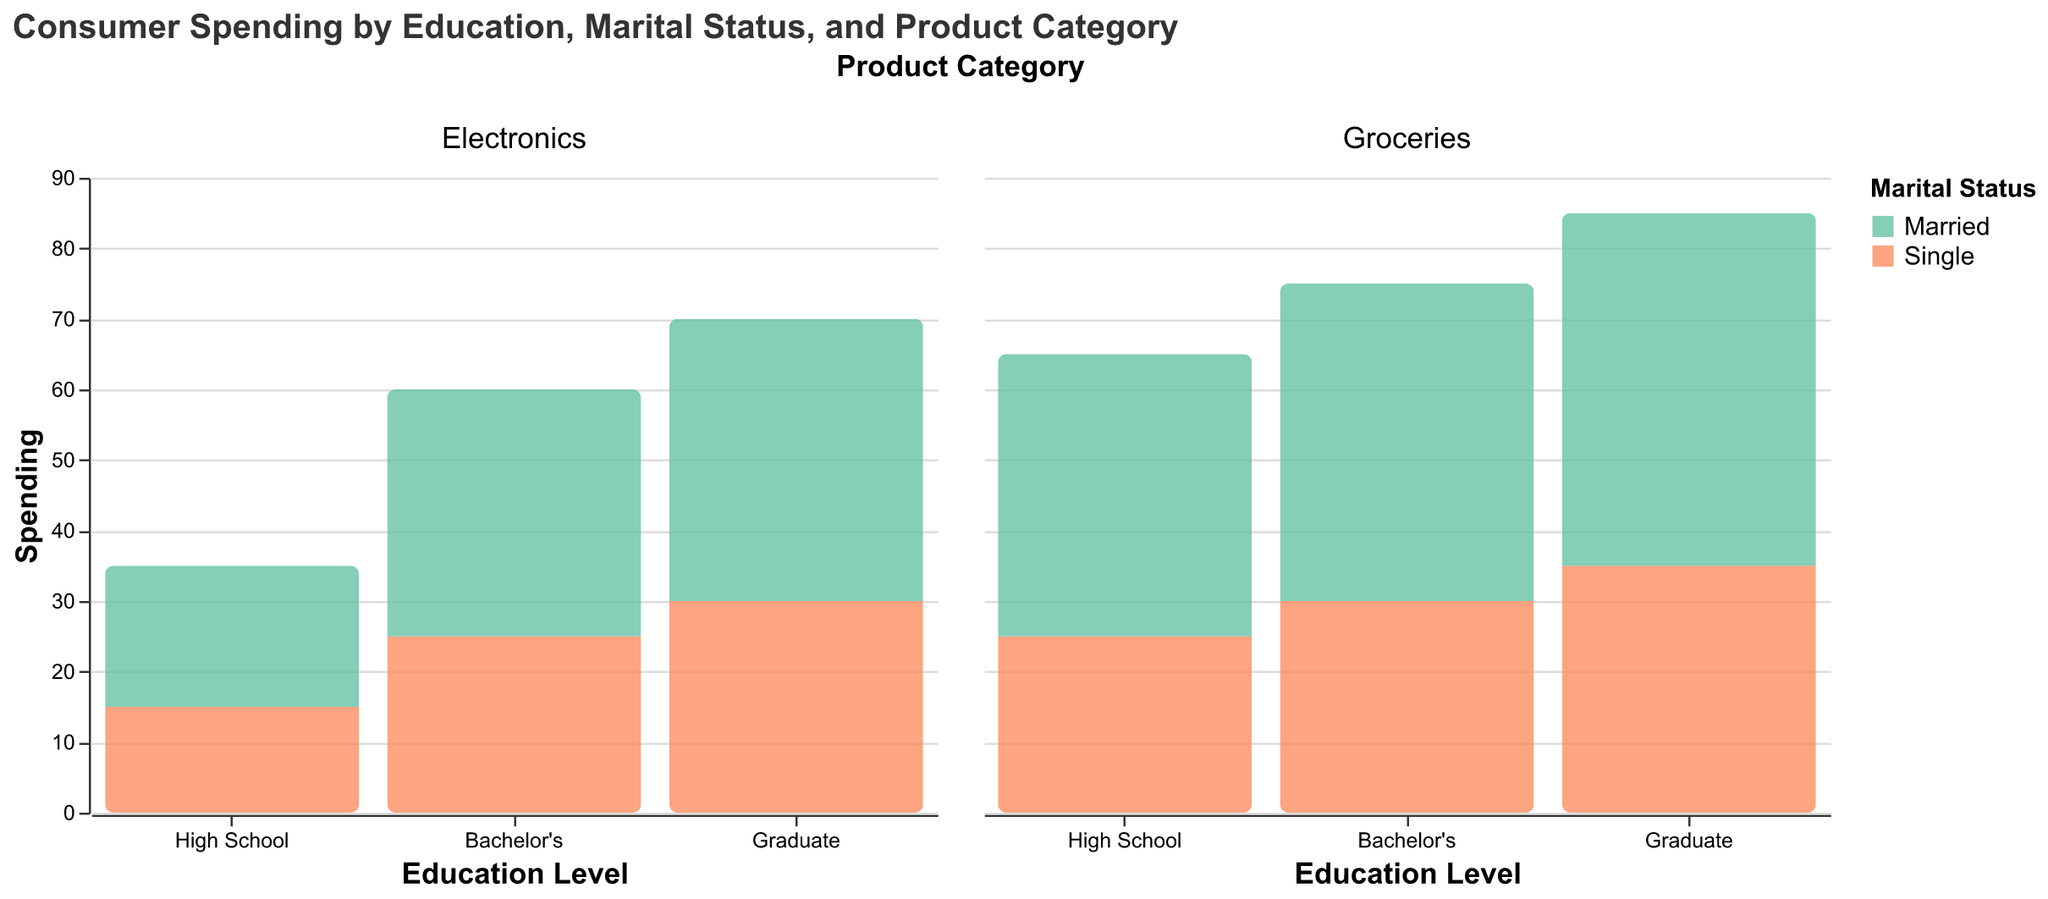What is the title of the figure? The title is usually displayed at the top of the figure. In this case, the title is "Consumer Spending by Education, Marital Status, and Product Category".
Answer: Consumer Spending by Education, Marital Status, and Product Category Which color represents the spending of married individuals in the plot? The color key in the legend indicates which color corresponds to each marital status. Here, "Married" is represented by the reddish color (#fc8d62).
Answer: Reddish color How much do single individuals with a Bachelor's degree spend on electronics? Look for the bar that corresponds to "Single" under the Bachelor's education category in the electronics column. According to the data, it shows a spending of 25.
Answer: 25 Which education level has the highest spending on groceries for married individuals? Observe the bar heights for "Married" in the groceries column across all education levels. The tallest bar is under Graduate education, with a spending of 50.
Answer: Graduate Compare the spending on electronics between single individuals with a Bachelor's degree and married individuals with a High School education. Who spends more? Examine the two relevant bars: one for "Single" with a Bachelor's degree in electronics and one for "Married" with a High School education in electronics. The bar for "Single" with a Bachelor's is higher (25) compared to "Married" with a High School (20).
Answer: Single individuals with a Bachelor's degree What is the sum of spending on groceries for single individuals across all education levels? Sum the grocery spending for single individuals from all education levels: 25 (High School), 30 (Bachelor's), and 35 (Graduate). The sum is 25 + 30 + 35 = 90.
Answer: 90 Which group has the lowest spending on electronics? Identify the shortest bar in the electronics column across all groups. The shortest bar represents single individuals with a High School education, with a spending of 15.
Answer: High School Single How does the spending on groceries by married graduates compare to that of married individuals with a Bachelor's degree? Compare the heights of the two bars for "Married" in the groceries column under Graduate and Bachelor's education levels. The bar under Graduates is higher (50) than the bar under Bachelor's (45).
Answer: Higher for Graduates What is the difference in spending on electronics between married individuals with a Bachelor's degree and married individuals with a Graduate degree? Subtract the spending of "Married" with a Bachelor's (35) from the spending of "Married" with a Graduate (40). The difference is 40 - 35 = 5.
Answer: 5 Calculate the average spending on groceries by single individuals with a High School and Graduate education. Sum the grocery spending for single individuals with High School (25) and Graduate education (35), then divide by the number of groups (2). The average is (25 + 35) / 2 = 30.
Answer: 30 